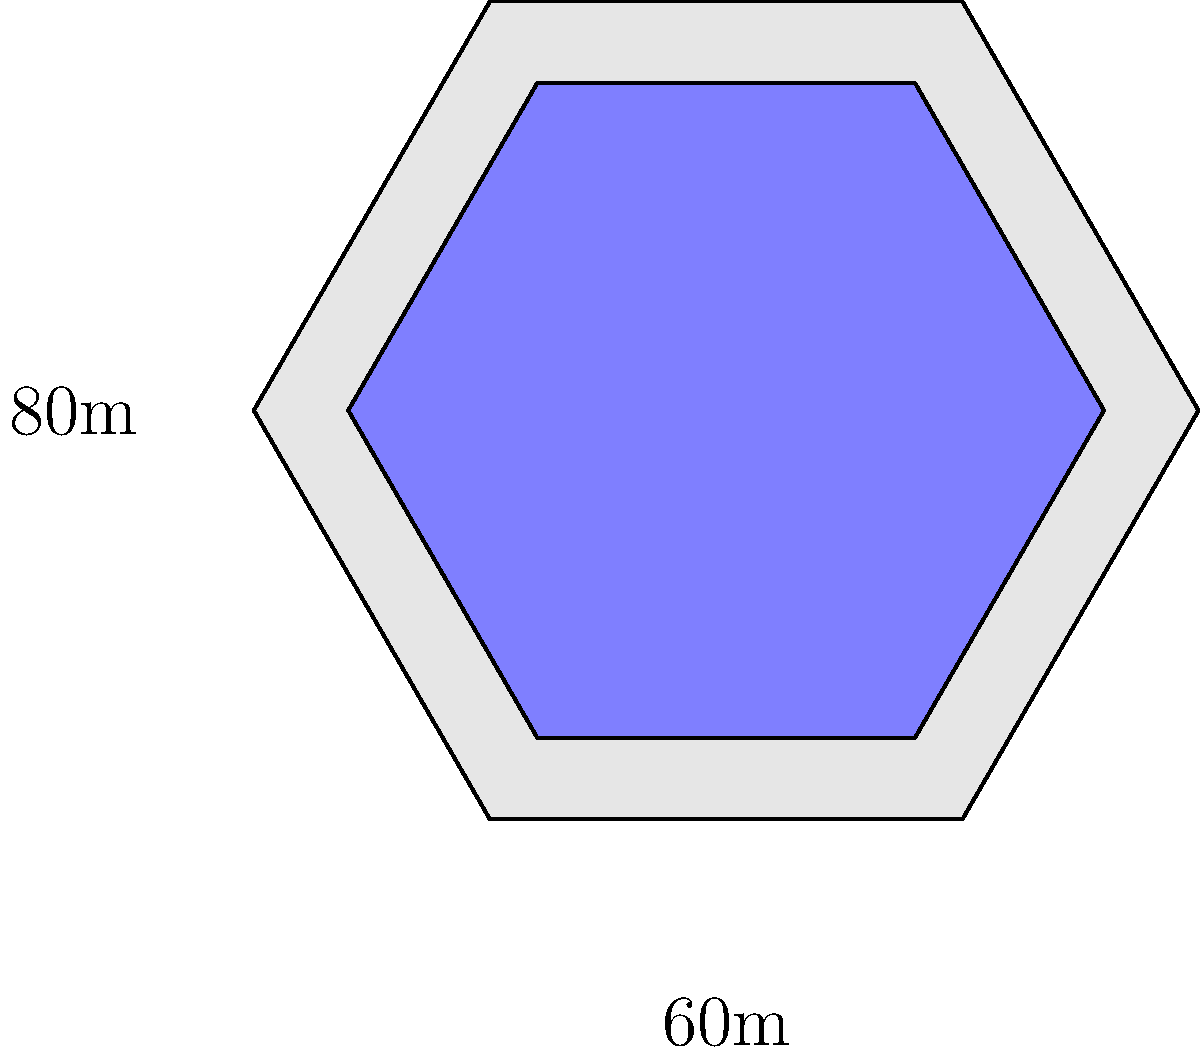A new controversial sports stadium has been designed with a hexagonal base and a slightly smaller hexagonal roof. The base has sides of 60m and the roof has sides of 48m. The height of the stadium is 80m. Calculate the total surface area of the stadium, including the base, roof, and six rectangular side walls. To calculate the total surface area, we need to find the areas of the base, roof, and side walls:

1. Area of the hexagonal base:
   $A_{base} = \frac{3\sqrt{3}}{2}s^2$, where $s$ is the side length
   $A_{base} = \frac{3\sqrt{3}}{2}(60)^2 = 9355.28 \text{ m}^2$

2. Area of the hexagonal roof:
   $A_{roof} = \frac{3\sqrt{3}}{2}(48)^2 = 5988.38 \text{ m}^2$

3. Area of one rectangular side wall:
   $A_{wall} = 60 \times 80 = 4800 \text{ m}^2$

4. Total area of all six side walls:
   $A_{walls} = 6 \times 4800 = 28800 \text{ m}^2$

5. Total surface area:
   $A_{total} = A_{base} + A_{roof} + A_{walls}$
   $A_{total} = 9355.28 + 5988.38 + 28800 = 44143.66 \text{ m}^2$
Answer: $44143.66 \text{ m}^2$ 